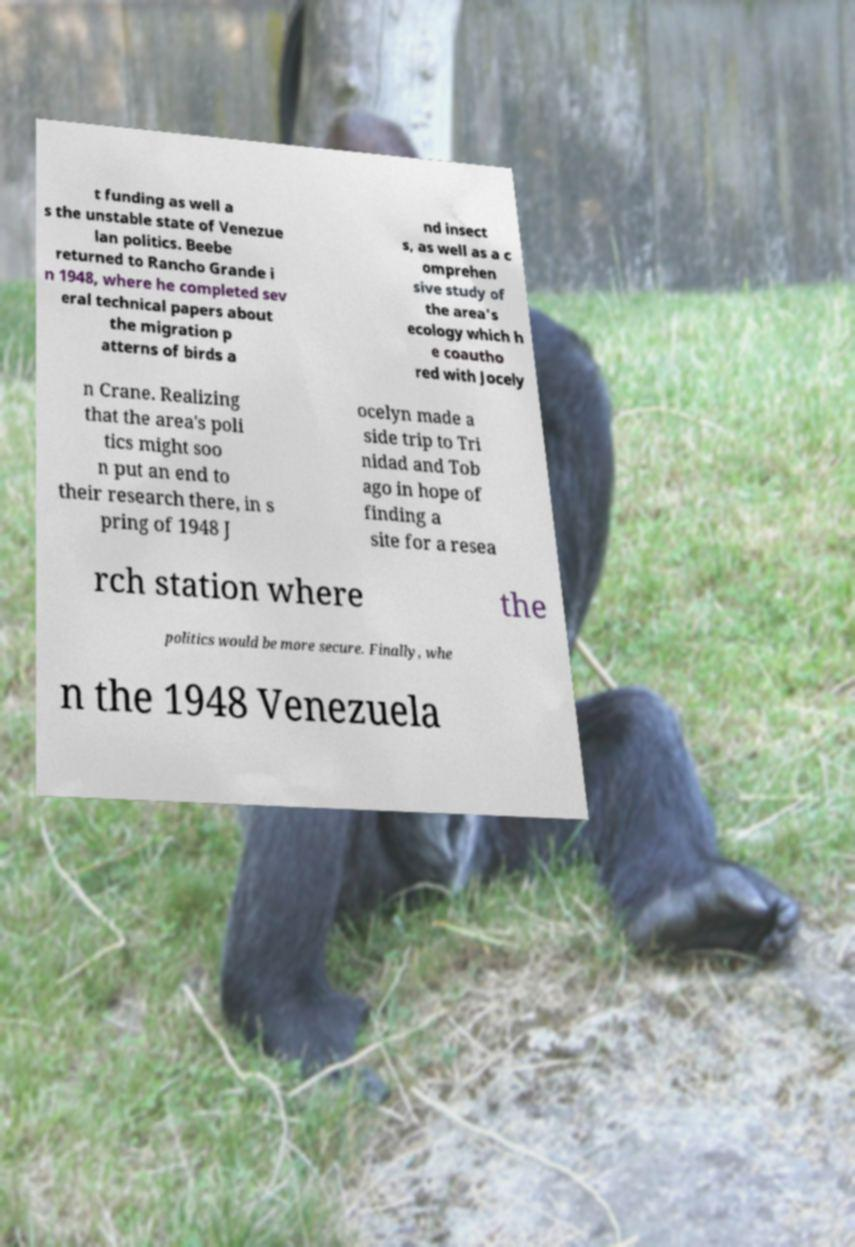Can you read and provide the text displayed in the image?This photo seems to have some interesting text. Can you extract and type it out for me? t funding as well a s the unstable state of Venezue lan politics. Beebe returned to Rancho Grande i n 1948, where he completed sev eral technical papers about the migration p atterns of birds a nd insect s, as well as a c omprehen sive study of the area's ecology which h e coautho red with Jocely n Crane. Realizing that the area's poli tics might soo n put an end to their research there, in s pring of 1948 J ocelyn made a side trip to Tri nidad and Tob ago in hope of finding a site for a resea rch station where the politics would be more secure. Finally, whe n the 1948 Venezuela 